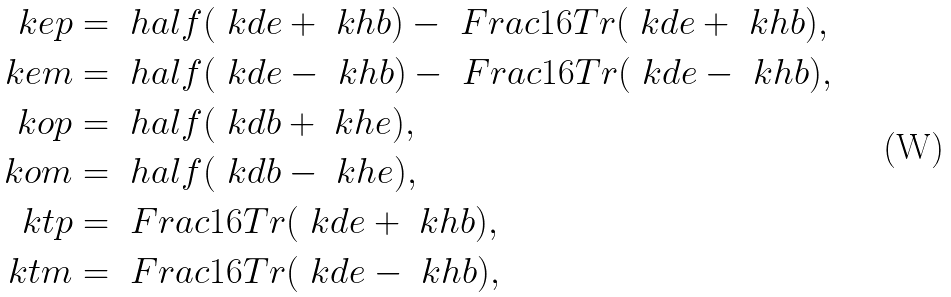<formula> <loc_0><loc_0><loc_500><loc_500>\ k e p & = \ h a l f ( \ k d e + \ k h b ) - \ F r a c 1 6 T r ( \ k d e + \ k h b ) , \\ \ k e m & = \ h a l f ( \ k d e - \ k h b ) - \ F r a c 1 6 T r ( \ k d e - \ k h b ) , \\ \ k o p & = \ h a l f ( \ k d b + \ k h e ) , \\ \ k o m & = \ h a l f ( \ k d b - \ k h e ) , \\ \ k t p & = \ F r a c 1 6 T r ( \ k d e + \ k h b ) , \\ \ k t m & = \ F r a c 1 6 T r ( \ k d e - \ k h b ) ,</formula> 